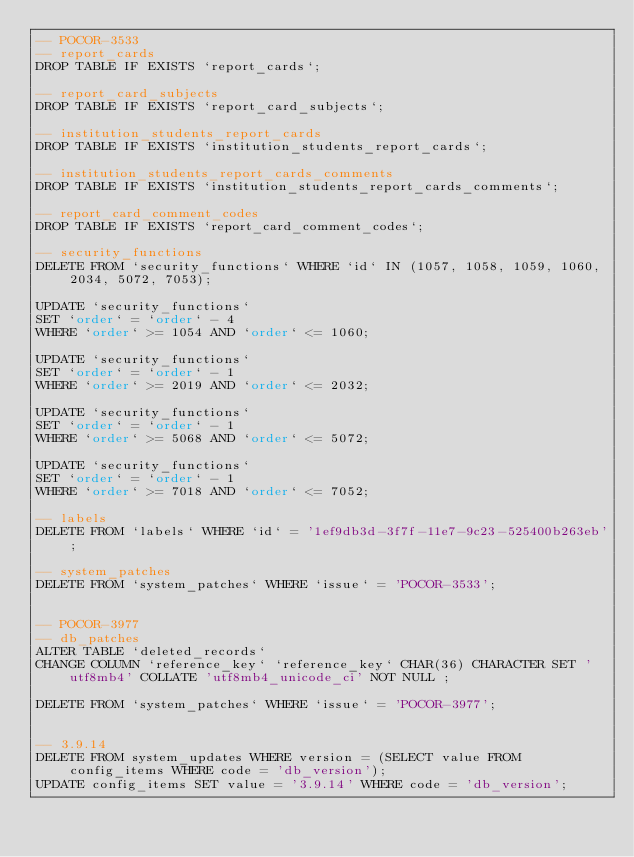Convert code to text. <code><loc_0><loc_0><loc_500><loc_500><_SQL_>-- POCOR-3533
-- report_cards
DROP TABLE IF EXISTS `report_cards`;

-- report_card_subjects
DROP TABLE IF EXISTS `report_card_subjects`;

-- institution_students_report_cards
DROP TABLE IF EXISTS `institution_students_report_cards`;

-- institution_students_report_cards_comments
DROP TABLE IF EXISTS `institution_students_report_cards_comments`;

-- report_card_comment_codes
DROP TABLE IF EXISTS `report_card_comment_codes`;

-- security_functions
DELETE FROM `security_functions` WHERE `id` IN (1057, 1058, 1059, 1060, 2034, 5072, 7053);

UPDATE `security_functions`
SET `order` = `order` - 4
WHERE `order` >= 1054 AND `order` <= 1060;

UPDATE `security_functions`
SET `order` = `order` - 1
WHERE `order` >= 2019 AND `order` <= 2032;

UPDATE `security_functions`
SET `order` = `order` - 1
WHERE `order` >= 5068 AND `order` <= 5072;

UPDATE `security_functions`
SET `order` = `order` - 1
WHERE `order` >= 7018 AND `order` <= 7052;

-- labels
DELETE FROM `labels` WHERE `id` = '1ef9db3d-3f7f-11e7-9c23-525400b263eb';

-- system_patches
DELETE FROM `system_patches` WHERE `issue` = 'POCOR-3533';


-- POCOR-3977
-- db_patches
ALTER TABLE `deleted_records`
CHANGE COLUMN `reference_key` `reference_key` CHAR(36) CHARACTER SET 'utf8mb4' COLLATE 'utf8mb4_unicode_ci' NOT NULL ;

DELETE FROM `system_patches` WHERE `issue` = 'POCOR-3977';


-- 3.9.14
DELETE FROM system_updates WHERE version = (SELECT value FROM config_items WHERE code = 'db_version');
UPDATE config_items SET value = '3.9.14' WHERE code = 'db_version';
</code> 